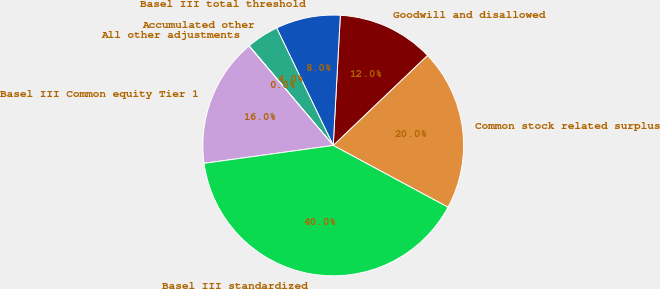<chart> <loc_0><loc_0><loc_500><loc_500><pie_chart><fcel>Common stock related surplus<fcel>Goodwill and disallowed<fcel>Basel III total threshold<fcel>Accumulated other<fcel>All other adjustments<fcel>Basel III Common equity Tier 1<fcel>Basel III standardized<nl><fcel>19.99%<fcel>12.0%<fcel>8.01%<fcel>4.02%<fcel>0.03%<fcel>16.0%<fcel>39.95%<nl></chart> 